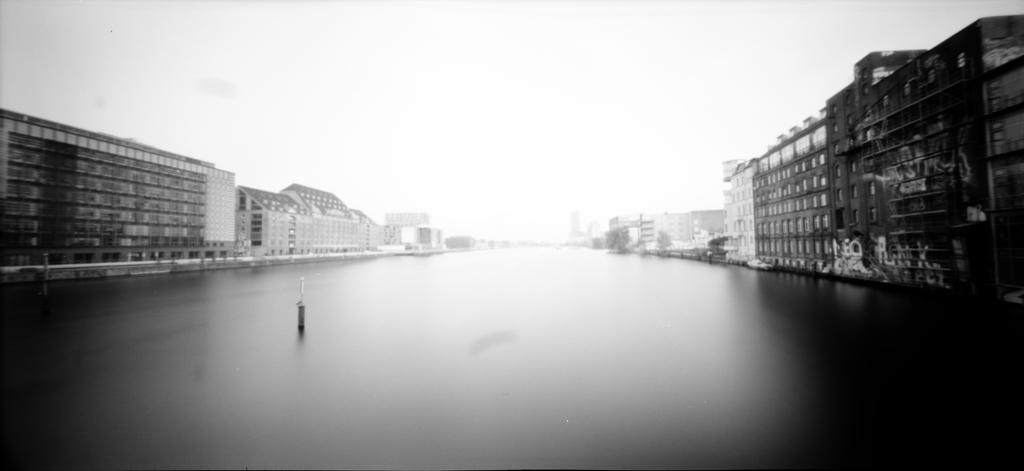Describe this image in one or two sentences. This is a black and white image. We can see an object in the path. There are a few buildings visible on both sides of the path. 